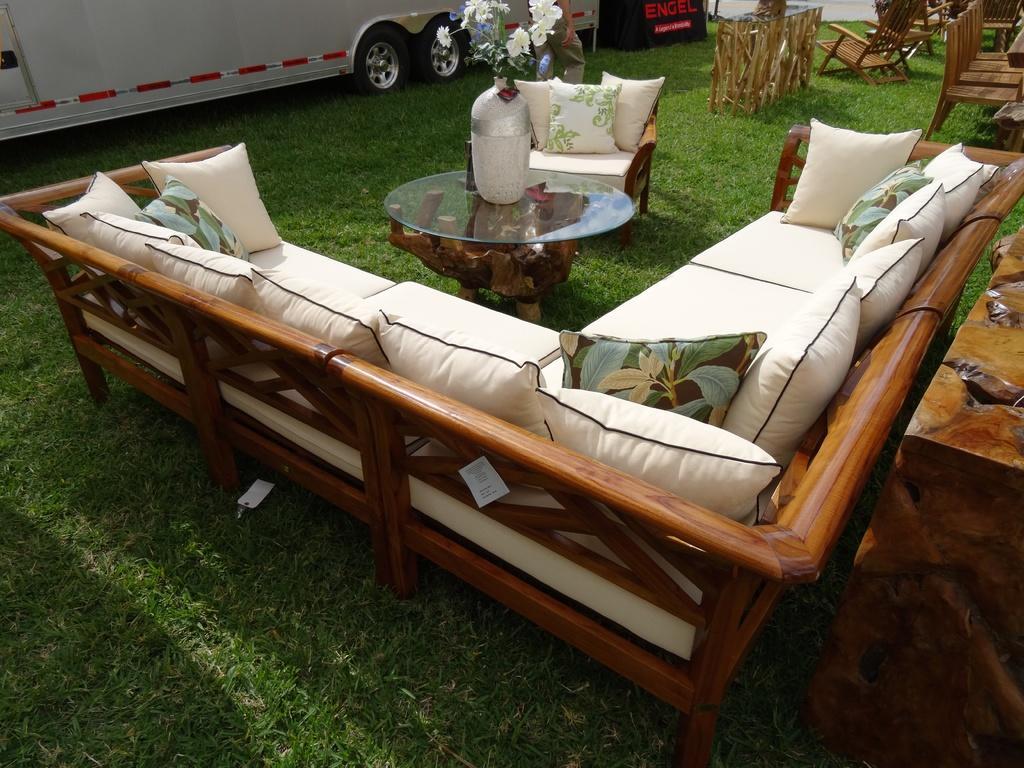In one or two sentences, can you explain what this image depicts? There is a vehicle parked on the ground and in front of that there is a sofa placed on which some cushions are placed, beneath that there is a table on which a flower vase was placed. And just beside that there are some wooden chairs placed. 